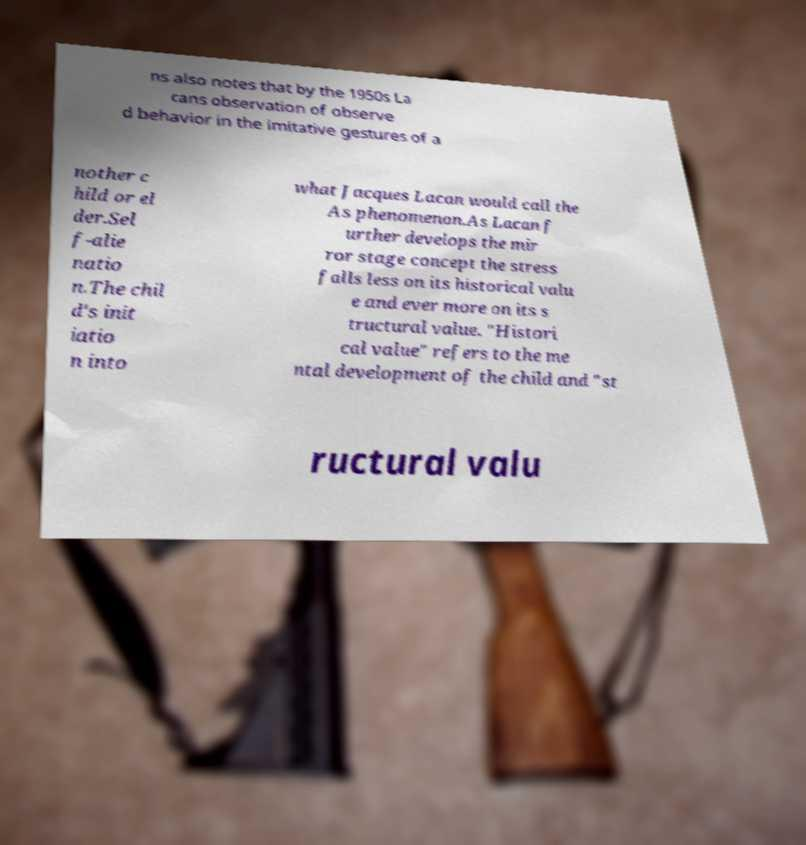For documentation purposes, I need the text within this image transcribed. Could you provide that? ns also notes that by the 1950s La cans observation of observe d behavior in the imitative gestures of a nother c hild or el der.Sel f-alie natio n.The chil d's init iatio n into what Jacques Lacan would call the As phenomenon.As Lacan f urther develops the mir ror stage concept the stress falls less on its historical valu e and ever more on its s tructural value. "Histori cal value" refers to the me ntal development of the child and "st ructural valu 